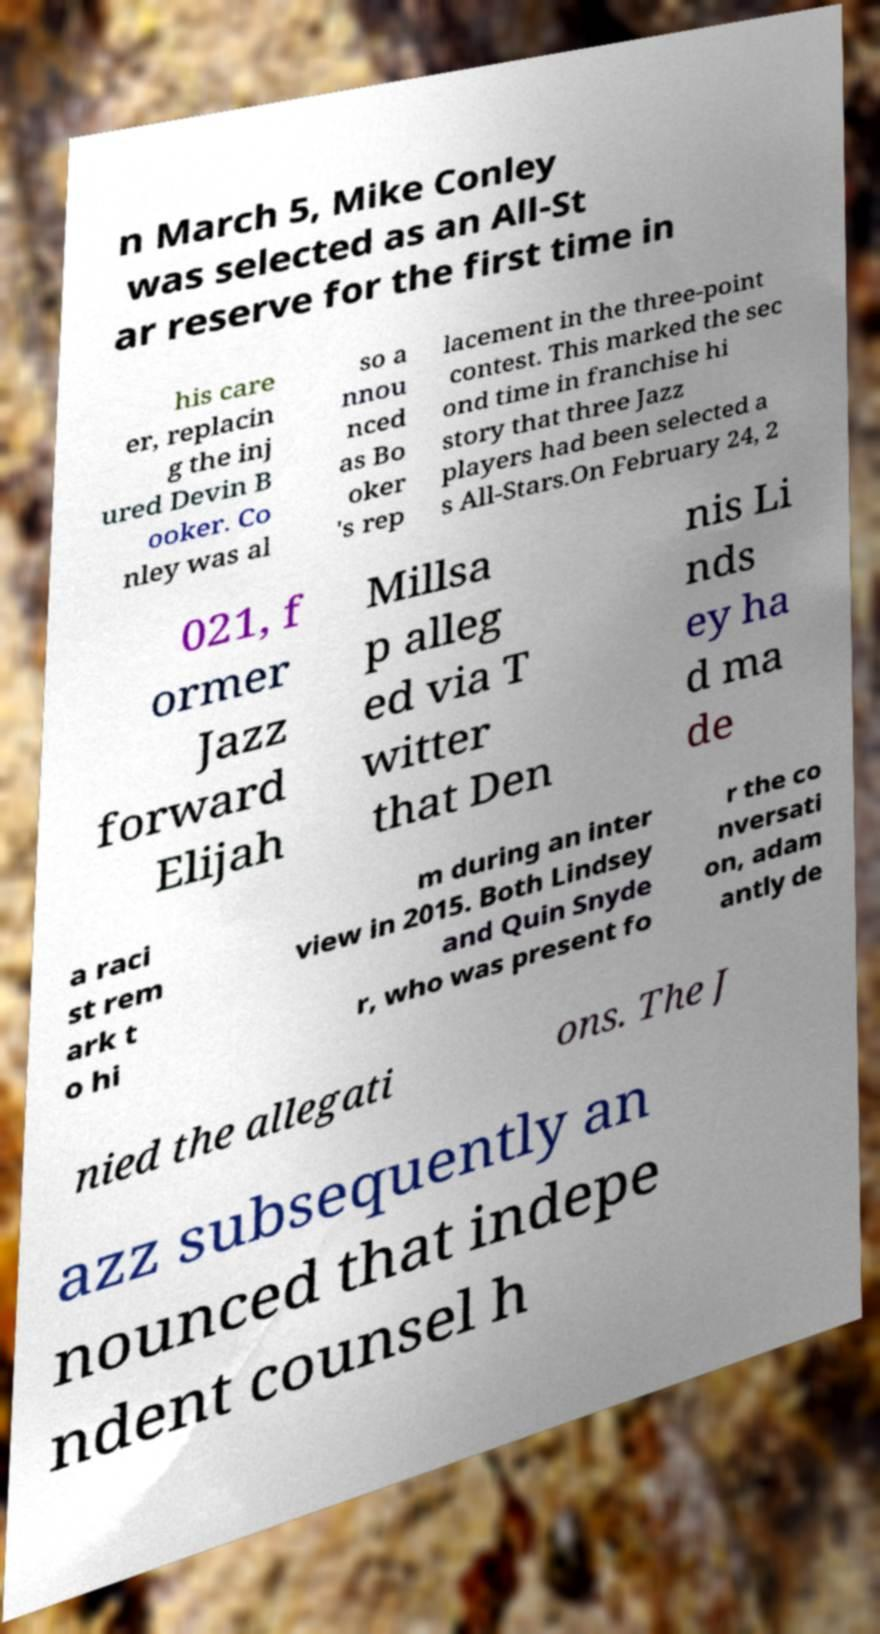Please read and relay the text visible in this image. What does it say? n March 5, Mike Conley was selected as an All-St ar reserve for the first time in his care er, replacin g the inj ured Devin B ooker. Co nley was al so a nnou nced as Bo oker 's rep lacement in the three-point contest. This marked the sec ond time in franchise hi story that three Jazz players had been selected a s All-Stars.On February 24, 2 021, f ormer Jazz forward Elijah Millsa p alleg ed via T witter that Den nis Li nds ey ha d ma de a raci st rem ark t o hi m during an inter view in 2015. Both Lindsey and Quin Snyde r, who was present fo r the co nversati on, adam antly de nied the allegati ons. The J azz subsequently an nounced that indepe ndent counsel h 